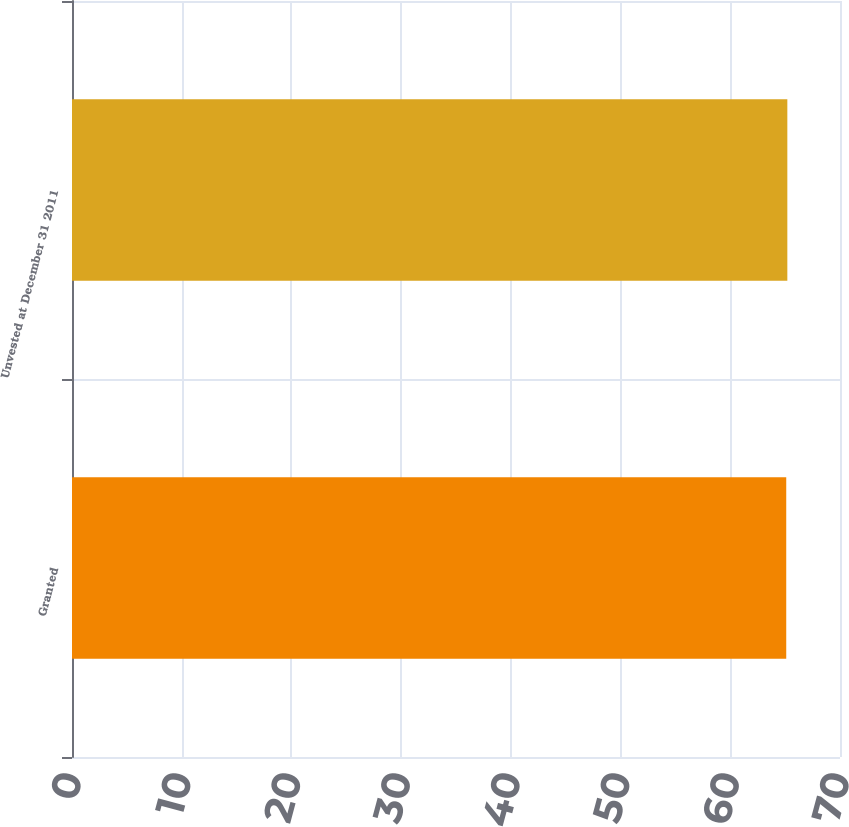<chart> <loc_0><loc_0><loc_500><loc_500><bar_chart><fcel>Granted<fcel>Unvested at December 31 2011<nl><fcel>65.1<fcel>65.2<nl></chart> 